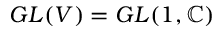<formula> <loc_0><loc_0><loc_500><loc_500>G L ( V ) = G L ( 1 , \mathbb { C } )</formula> 